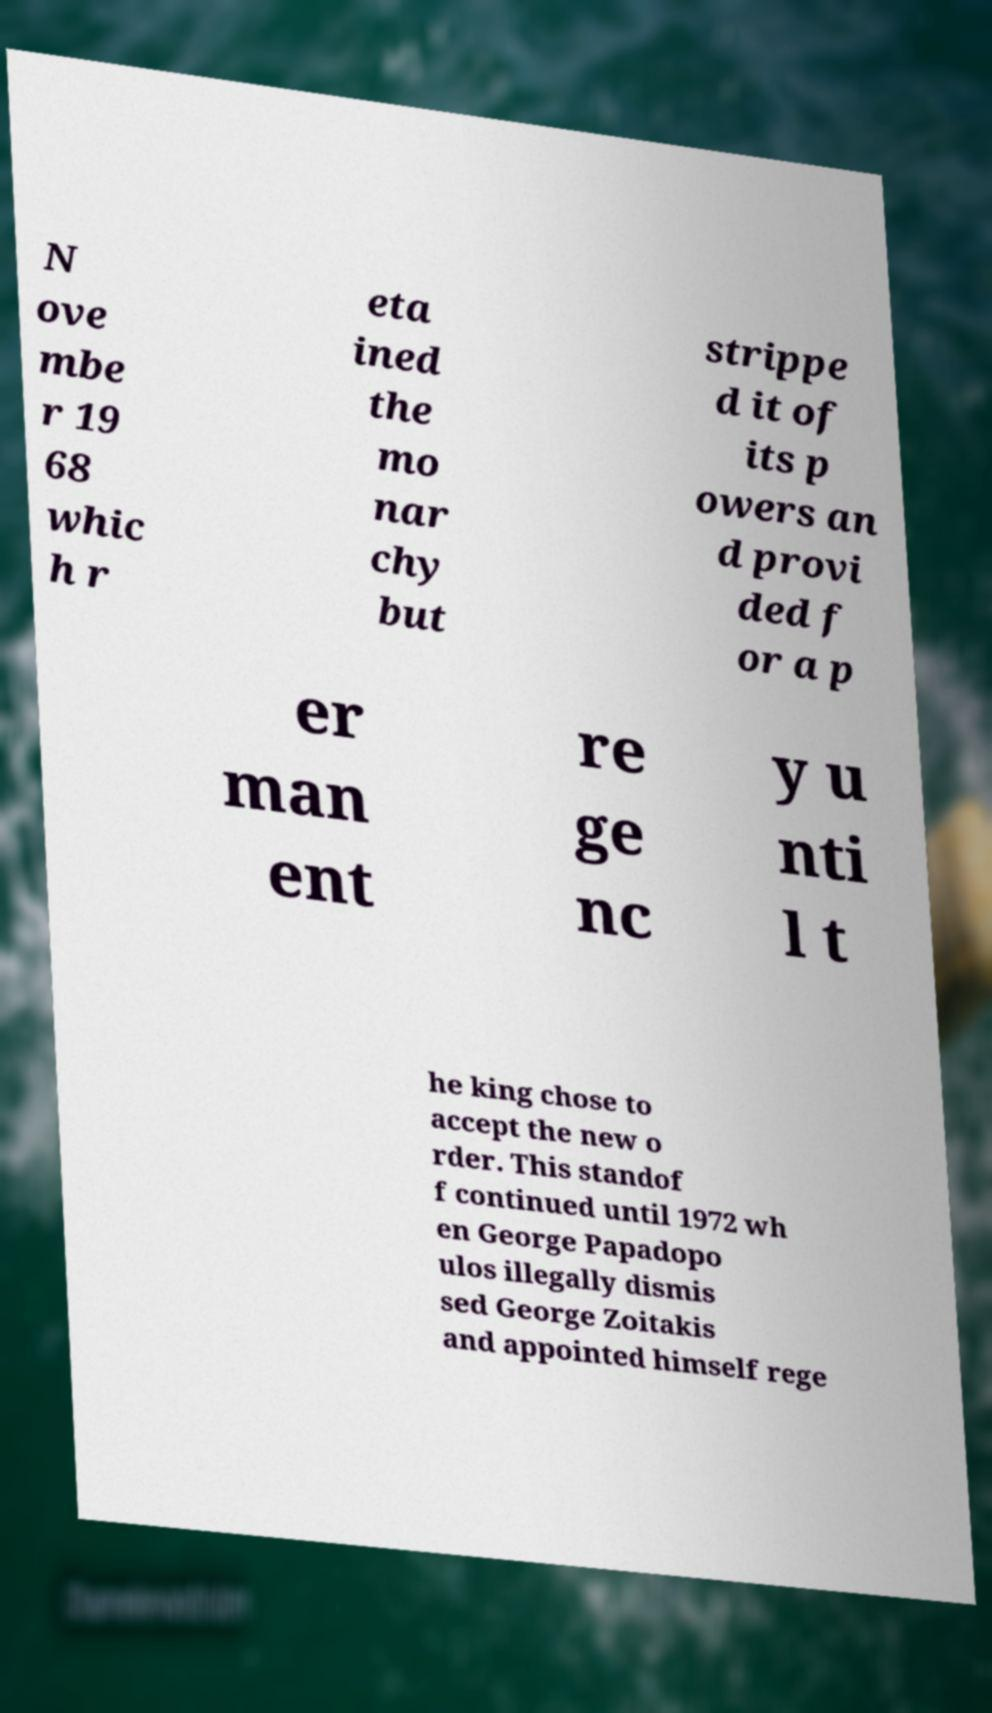I need the written content from this picture converted into text. Can you do that? N ove mbe r 19 68 whic h r eta ined the mo nar chy but strippe d it of its p owers an d provi ded f or a p er man ent re ge nc y u nti l t he king chose to accept the new o rder. This standof f continued until 1972 wh en George Papadopo ulos illegally dismis sed George Zoitakis and appointed himself rege 